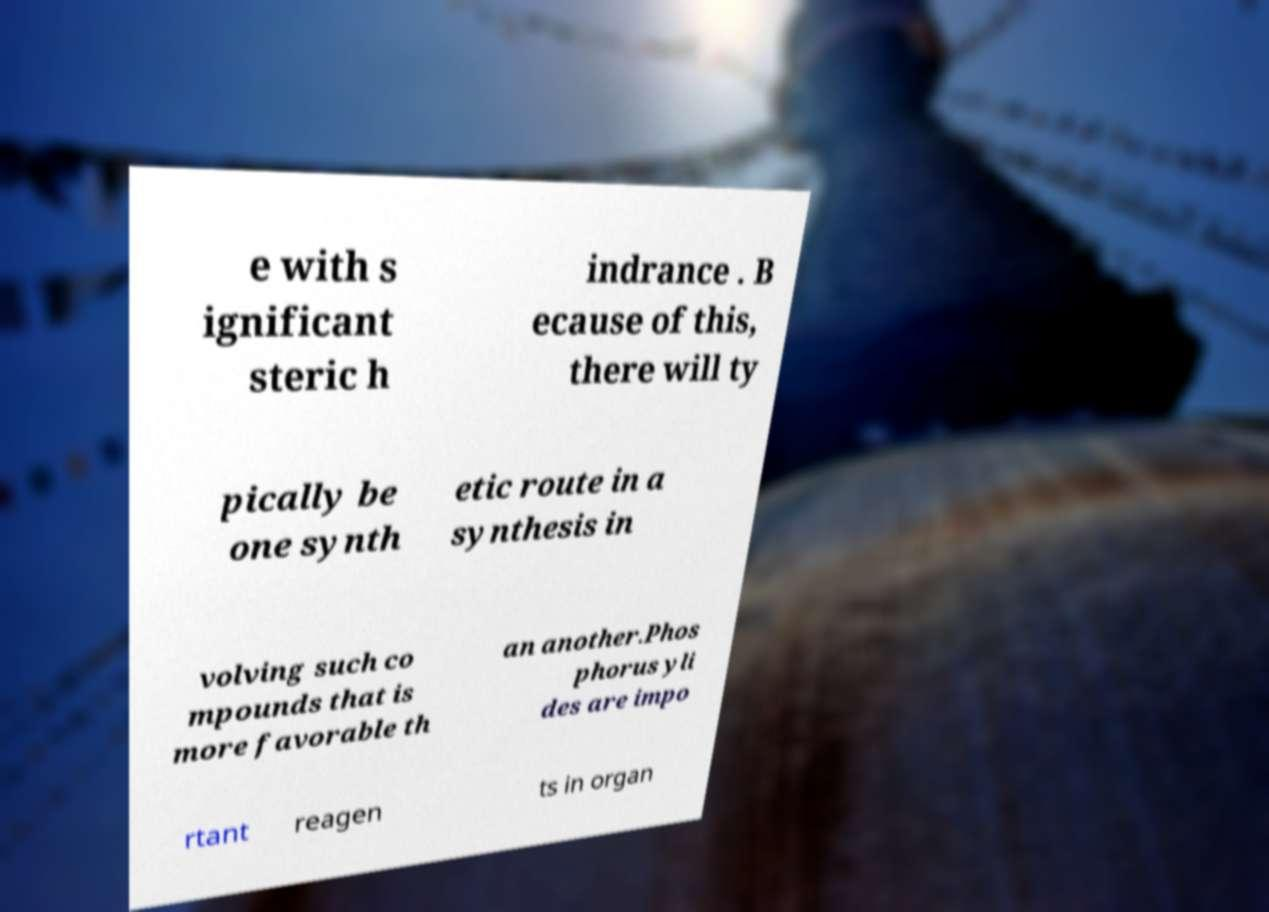Could you extract and type out the text from this image? e with s ignificant steric h indrance . B ecause of this, there will ty pically be one synth etic route in a synthesis in volving such co mpounds that is more favorable th an another.Phos phorus yli des are impo rtant reagen ts in organ 